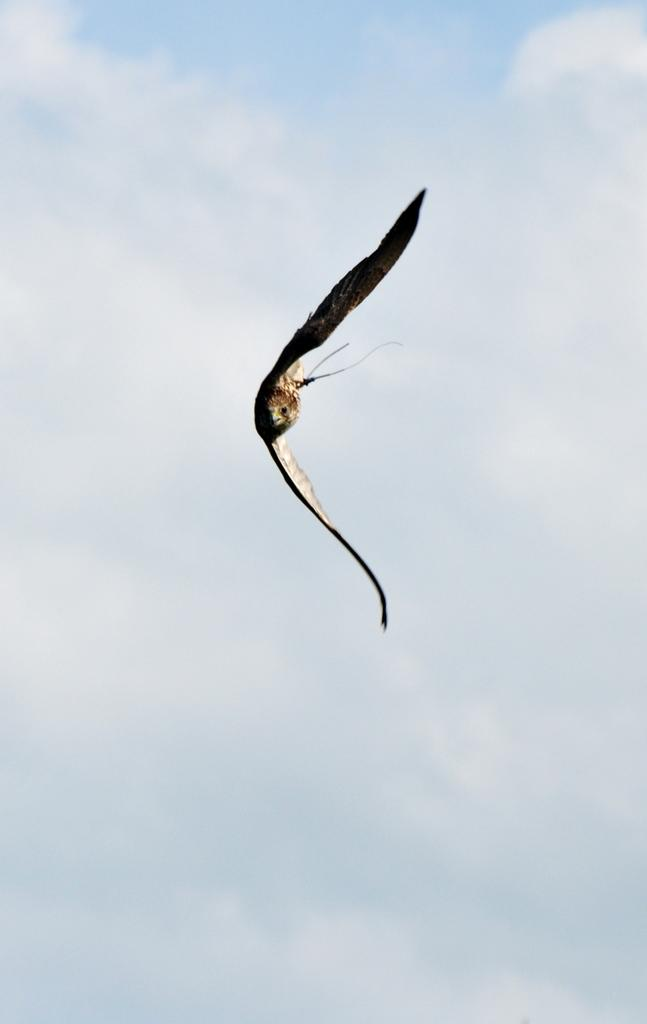What type of animal is present in the image? There is a bird in the image. What is the bird doing in the image? The bird is flying. What can be seen in the background of the image? The sky is visible in the background of the image. Where is the crown that the bird is wearing in the image? There is no crown present in the image, as the bird is not wearing any accessories. 